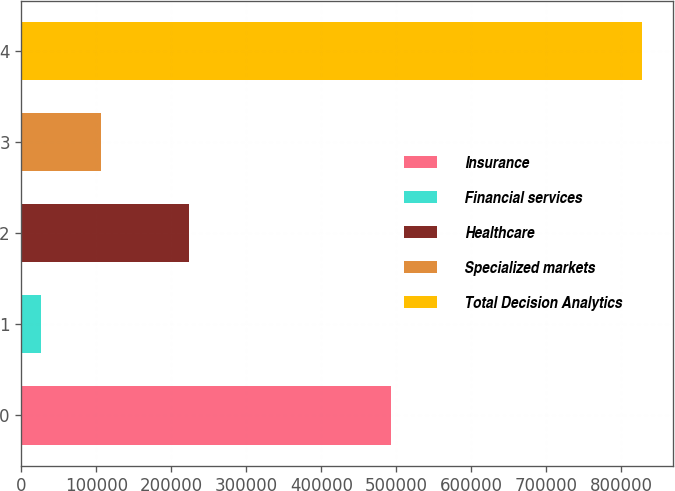Convert chart to OTSL. <chart><loc_0><loc_0><loc_500><loc_500><bar_chart><fcel>Insurance<fcel>Financial services<fcel>Healthcare<fcel>Specialized markets<fcel>Total Decision Analytics<nl><fcel>493456<fcel>26567<fcel>222955<fcel>106744<fcel>828342<nl></chart> 